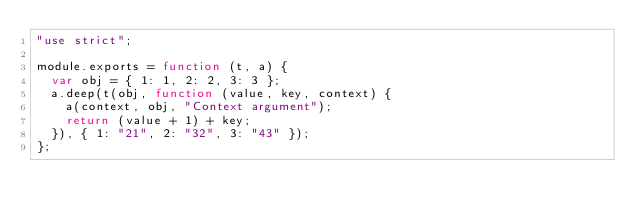<code> <loc_0><loc_0><loc_500><loc_500><_JavaScript_>"use strict";

module.exports = function (t, a) {
	var obj = { 1: 1, 2: 2, 3: 3 };
	a.deep(t(obj, function (value, key, context) {
		a(context, obj, "Context argument");
		return (value + 1) + key;
	}), { 1: "21", 2: "32", 3: "43" });
};
</code> 